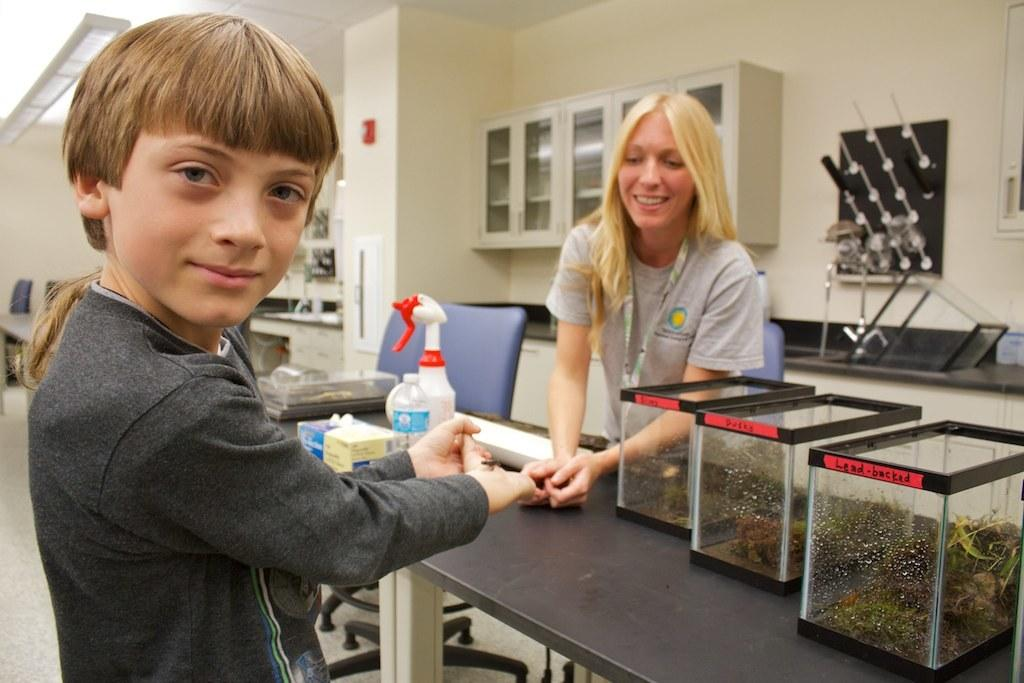How many people are present in the image? There are two people in the image. What objects can be seen in the image besides the people? There are boxes, bottles, papers on the table, chairs, and racks in the image. What might the people be using the chairs for? The chairs might be used for sitting or working at the table. What could the racks be used for in the image? The racks could be used for storage or displaying items. What type of wax can be seen melting on the stranger's journey in the image? There is no wax, stranger, or journey depicted in the image; it only shows two people, boxes, bottles, papers on the table, chairs, and racks. 